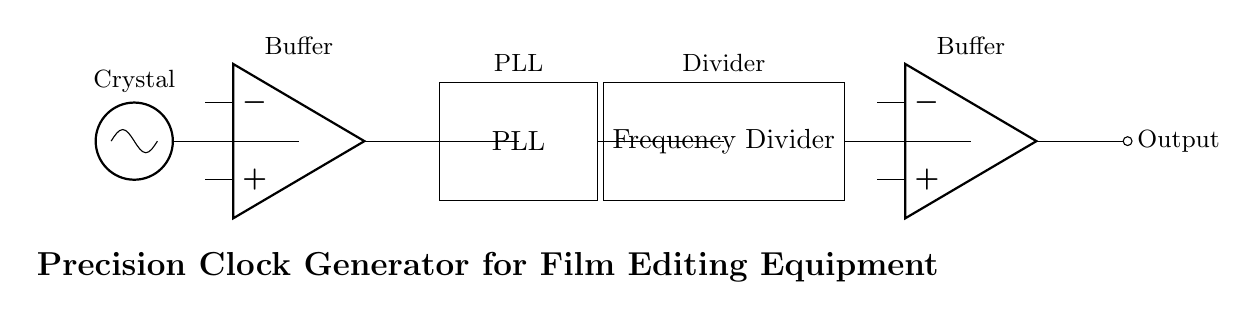What type of oscillator is used in this circuit? The circuit diagram shows a crystal oscillator, which is indicated by the oscillator symbol at the far left. This is typically used for stable frequency generation.
Answer: Crystal oscillator What is the purpose of the buffer in this circuit? The buffer, represented as an operational amplifier, serves to isolate the crystal oscillator output from other components, preventing loading effects and providing a stronger signal for further processing.
Answer: To isolate the signal How many main components are in this precision clock generator? The diagram includes five main components: a crystal oscillator, a buffer, a phase-locked loop (PLL), a frequency divider, and an output buffer. Counting these gives a total of five.
Answer: Five What does PLL stand for in this circuit? The acronym PLL stands for phase-locked loop, which is a control system that generates a signal that has a fixed relation to the phase of a reference signal, thus stabilizing the output frequency.
Answer: Phase-locked loop What is the function of the frequency divider? The frequency divider reduces the frequency of the signal coming from the PLL, allowing for the output frequency to match the desired timing for film editing.
Answer: To reduce frequency In what application would this circuit likely be used? Given that the circuit is identified as a precision clock generator for film editing equipment, it is specifically designed for use in film editing environments where accurate timing is crucial.
Answer: Film editing equipment What type of output does the circuit provide? The circuit culminates with an output buffer, which essentially provides a clean and strong signal output suitable for further processing or use in film editing systems.
Answer: Strong signal output 